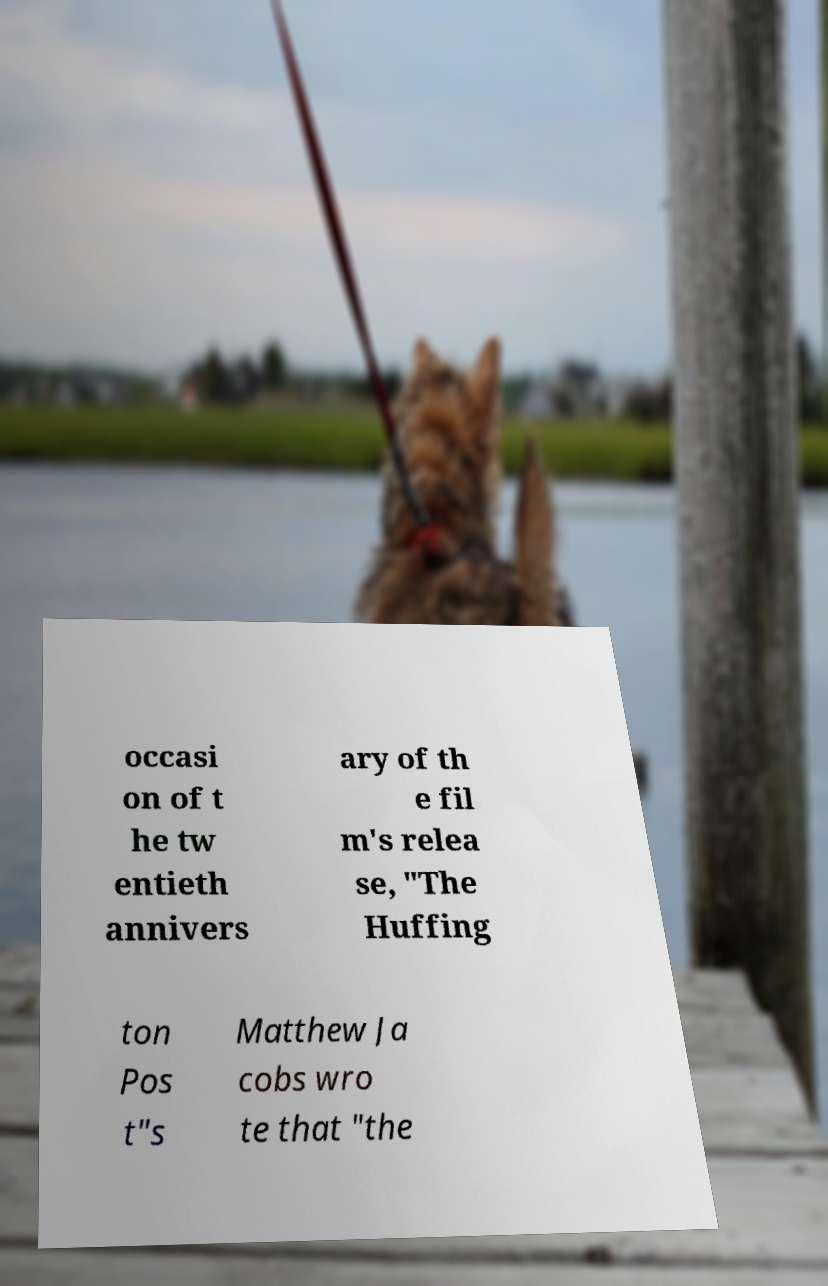I need the written content from this picture converted into text. Can you do that? occasi on of t he tw entieth annivers ary of th e fil m's relea se, "The Huffing ton Pos t"s Matthew Ja cobs wro te that "the 